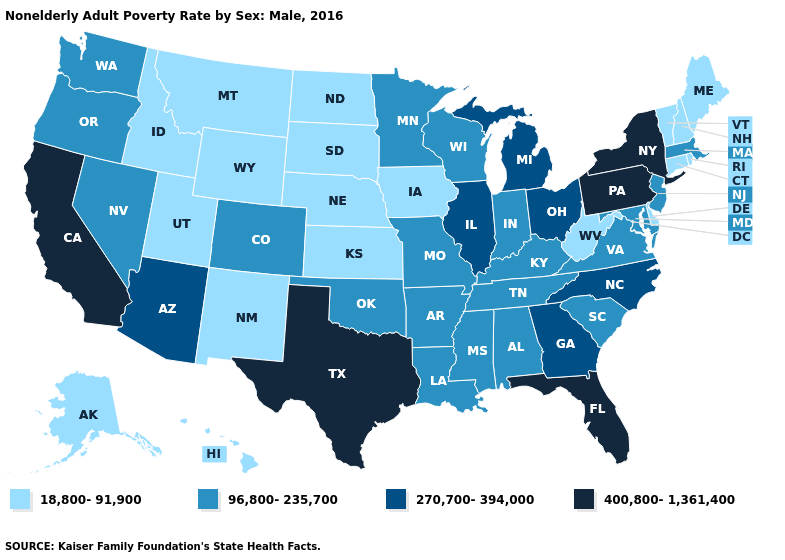What is the lowest value in the West?
Write a very short answer. 18,800-91,900. What is the value of Idaho?
Give a very brief answer. 18,800-91,900. Does the first symbol in the legend represent the smallest category?
Quick response, please. Yes. Does Maine have the lowest value in the Northeast?
Be succinct. Yes. Name the states that have a value in the range 96,800-235,700?
Give a very brief answer. Alabama, Arkansas, Colorado, Indiana, Kentucky, Louisiana, Maryland, Massachusetts, Minnesota, Mississippi, Missouri, Nevada, New Jersey, Oklahoma, Oregon, South Carolina, Tennessee, Virginia, Washington, Wisconsin. What is the value of Alabama?
Keep it brief. 96,800-235,700. What is the lowest value in the USA?
Be succinct. 18,800-91,900. Which states have the lowest value in the West?
Keep it brief. Alaska, Hawaii, Idaho, Montana, New Mexico, Utah, Wyoming. What is the lowest value in the West?
Be succinct. 18,800-91,900. Does New Hampshire have the lowest value in the USA?
Be succinct. Yes. What is the lowest value in the USA?
Be succinct. 18,800-91,900. Which states have the highest value in the USA?
Give a very brief answer. California, Florida, New York, Pennsylvania, Texas. Which states hav the highest value in the South?
Keep it brief. Florida, Texas. What is the value of Delaware?
Be succinct. 18,800-91,900. Name the states that have a value in the range 270,700-394,000?
Answer briefly. Arizona, Georgia, Illinois, Michigan, North Carolina, Ohio. 